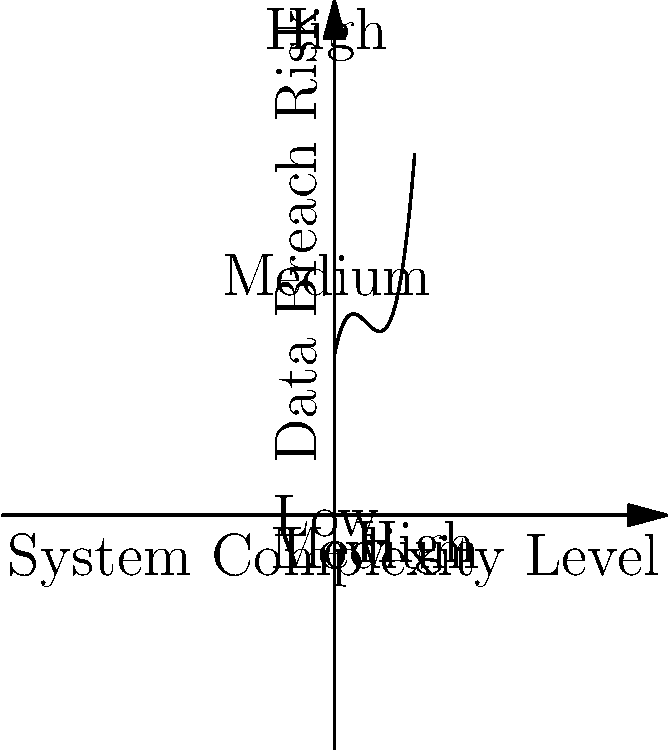Given the polynomial function $f(x) = 0.5x^3 - 3x^2 + 5x + 10$ representing the data breach risk (y-axis) in relation to system complexity level (x-axis), at which complexity level does the risk start to increase rapidly? To determine where the risk starts to increase rapidly, we need to analyze the rate of change of the function. This is done by finding the derivative of $f(x)$.

1. Calculate the first derivative:
   $f'(x) = 1.5x^2 - 6x + 5$

2. Find the critical points by setting $f'(x) = 0$:
   $1.5x^2 - 6x + 5 = 0$
   Solving this quadratic equation gives us $x ≈ 0.85$ and $x ≈ 3.15$

3. The second derivative is:
   $f''(x) = 3x - 6$

4. Evaluate $f''(x)$ at the critical points:
   $f''(0.85) < 0$ and $f''(3.15) > 0$

5. This indicates that $x ≈ 3.15$ is the point of inflection where the function changes from concave down to concave up.

6. On the graph, we can see that after this point (which corresponds to a "Medium-High" complexity level), the risk starts to increase more rapidly.

Therefore, the risk starts to increase rapidly at a medium-high system complexity level, corresponding to $x ≈ 3.15$ on the graph.
Answer: Medium-high complexity level (x ≈ 3.15) 